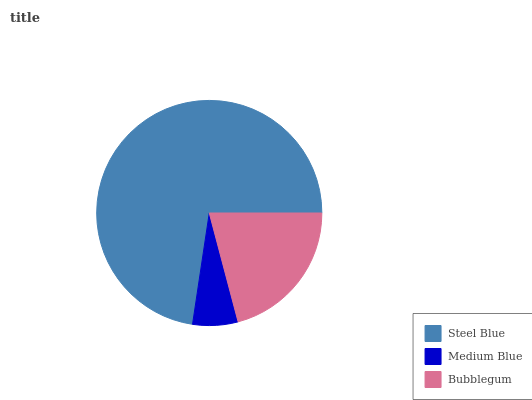Is Medium Blue the minimum?
Answer yes or no. Yes. Is Steel Blue the maximum?
Answer yes or no. Yes. Is Bubblegum the minimum?
Answer yes or no. No. Is Bubblegum the maximum?
Answer yes or no. No. Is Bubblegum greater than Medium Blue?
Answer yes or no. Yes. Is Medium Blue less than Bubblegum?
Answer yes or no. Yes. Is Medium Blue greater than Bubblegum?
Answer yes or no. No. Is Bubblegum less than Medium Blue?
Answer yes or no. No. Is Bubblegum the high median?
Answer yes or no. Yes. Is Bubblegum the low median?
Answer yes or no. Yes. Is Medium Blue the high median?
Answer yes or no. No. Is Steel Blue the low median?
Answer yes or no. No. 